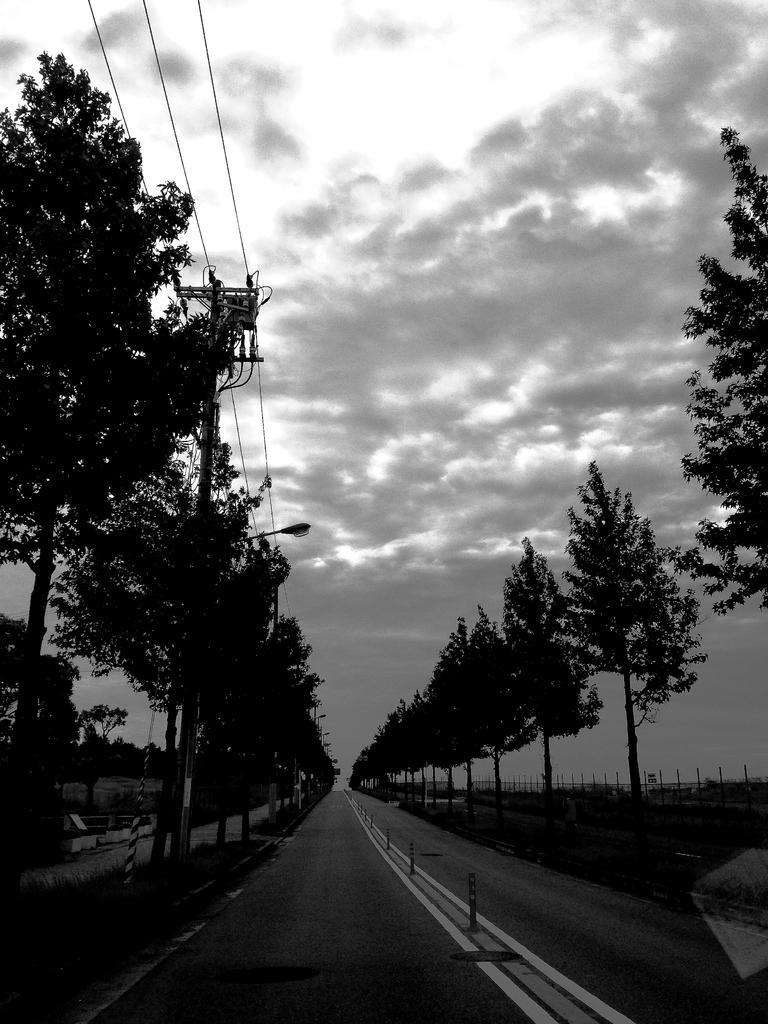In one or two sentences, can you explain what this image depicts? In this picture we can see trees on the right side and left side, on the left side we can see a pole, a light and wires, there is the sky and clouds at the top of the picture. 